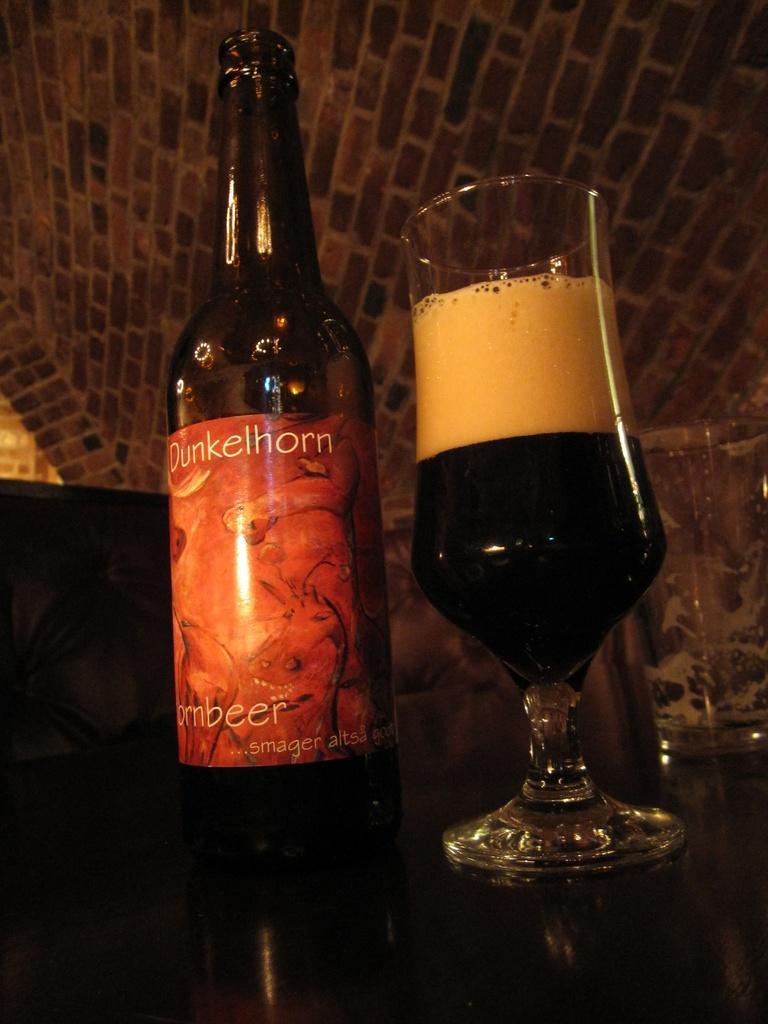Describe this image in one or two sentences. In this image I can see a bottle and a glass with drink in it. 